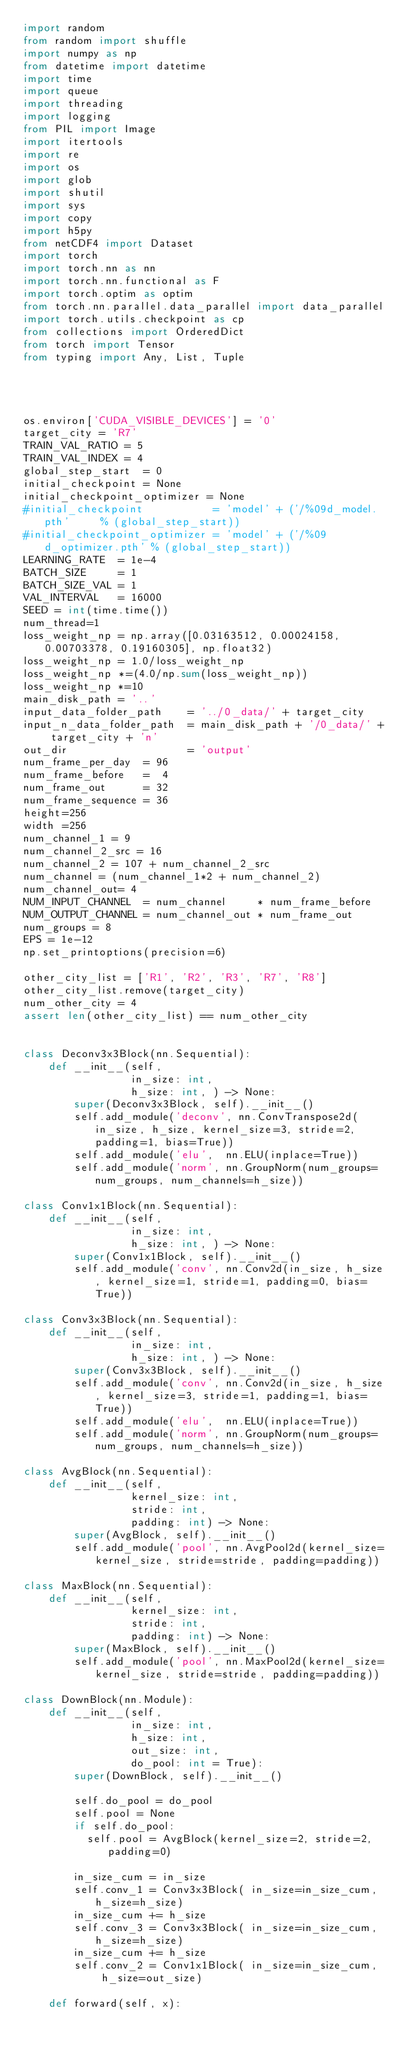Convert code to text. <code><loc_0><loc_0><loc_500><loc_500><_Python_>import random
from random import shuffle
import numpy as np
from datetime import datetime
import time
import queue
import threading
import logging
from PIL import Image
import itertools
import re
import os
import glob
import shutil
import sys
import copy
import h5py
from netCDF4 import Dataset
import torch
import torch.nn as nn
import torch.nn.functional as F
import torch.optim as optim
from torch.nn.parallel.data_parallel import data_parallel
import torch.utils.checkpoint as cp
from collections import OrderedDict
from torch import Tensor
from typing import Any, List, Tuple




os.environ['CUDA_VISIBLE_DEVICES'] = '0'
target_city = 'R7'
TRAIN_VAL_RATIO = 5             
TRAIN_VAL_INDEX = 4
global_step_start  = 0
initial_checkpoint = None
initial_checkpoint_optimizer = None
#initial_checkpoint           = 'model' + ('/%09d_model.pth'     % (global_step_start))
#initial_checkpoint_optimizer = 'model' + ('/%09d_optimizer.pth' % (global_step_start))
LEARNING_RATE  = 1e-4
BATCH_SIZE     = 1
BATCH_SIZE_VAL = 1       
VAL_INTERVAL   = 16000 
SEED = int(time.time())
num_thread=1
loss_weight_np = np.array([0.03163512, 0.00024158, 0.00703378, 0.19160305], np.float32)
loss_weight_np = 1.0/loss_weight_np            
loss_weight_np *=(4.0/np.sum(loss_weight_np))
loss_weight_np *=10
main_disk_path = '..'
input_data_folder_path    = '../0_data/' + target_city 
input_n_data_folder_path  = main_disk_path + '/0_data/' + target_city + 'n'
out_dir                   = 'output'
num_frame_per_day  = 96
num_frame_before   =  4   
num_frame_out      = 32
num_frame_sequence = 36
height=256
width =256
num_channel_1 = 9    
num_channel_2_src = 16 
num_channel_2 = 107 + num_channel_2_src
num_channel = (num_channel_1*2 + num_channel_2)
num_channel_out= 4
NUM_INPUT_CHANNEL  = num_channel     * num_frame_before
NUM_OUTPUT_CHANNEL = num_channel_out * num_frame_out
num_groups = 8
EPS = 1e-12
np.set_printoptions(precision=6)

other_city_list = ['R1', 'R2', 'R3', 'R7', 'R8']
other_city_list.remove(target_city)
num_other_city = 4
assert len(other_city_list) == num_other_city


class Deconv3x3Block(nn.Sequential):
    def __init__(self, 
                 in_size: int, 
                 h_size: int, ) -> None:
        super(Deconv3x3Block, self).__init__()
        self.add_module('deconv', nn.ConvTranspose2d(in_size, h_size, kernel_size=3, stride=2, padding=1, bias=True))
        self.add_module('elu',  nn.ELU(inplace=True))                                        
        self.add_module('norm', nn.GroupNorm(num_groups=num_groups, num_channels=h_size))    

class Conv1x1Block(nn.Sequential):
    def __init__(self, 
                 in_size: int, 
                 h_size: int, ) -> None:
        super(Conv1x1Block, self).__init__()
        self.add_module('conv', nn.Conv2d(in_size, h_size, kernel_size=1, stride=1, padding=0, bias=True))

class Conv3x3Block(nn.Sequential):
    def __init__(self, 
                 in_size: int, 
                 h_size: int, ) -> None:
        super(Conv3x3Block, self).__init__()
        self.add_module('conv', nn.Conv2d(in_size, h_size, kernel_size=3, stride=1, padding=1, bias=True))
        self.add_module('elu',  nn.ELU(inplace=True))                                        
        self.add_module('norm', nn.GroupNorm(num_groups=num_groups, num_channels=h_size))    

class AvgBlock(nn.Sequential):
    def __init__(self, 
                 kernel_size: int, 
                 stride: int, 
                 padding: int) -> None:
        super(AvgBlock, self).__init__()
        self.add_module('pool', nn.AvgPool2d(kernel_size=kernel_size, stride=stride, padding=padding))    
        
class MaxBlock(nn.Sequential):
    def __init__(self, 
                 kernel_size: int, 
                 stride: int, 
                 padding: int) -> None:
        super(MaxBlock, self).__init__()
        self.add_module('pool', nn.MaxPool2d(kernel_size=kernel_size, stride=stride, padding=padding))    

class DownBlock(nn.Module):
    def __init__(self, 
                 in_size: int, 
                 h_size: int, 
                 out_size: int, 
                 do_pool: int = True):
        super(DownBlock, self).__init__()     

        self.do_pool = do_pool
        self.pool = None
        if self.do_pool:
          self.pool = AvgBlock(kernel_size=2, stride=2, padding=0)

        in_size_cum = in_size  
        self.conv_1 = Conv3x3Block( in_size=in_size_cum, h_size=h_size)
        in_size_cum += h_size
        self.conv_3 = Conv3x3Block( in_size=in_size_cum, h_size=h_size)
        in_size_cum += h_size
        self.conv_2 = Conv1x1Block( in_size=in_size_cum,  h_size=out_size)

    def forward(self, x):
        </code> 